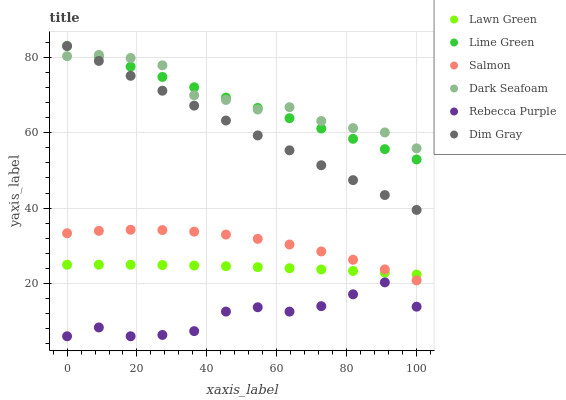Does Rebecca Purple have the minimum area under the curve?
Answer yes or no. Yes. Does Dark Seafoam have the maximum area under the curve?
Answer yes or no. Yes. Does Dim Gray have the minimum area under the curve?
Answer yes or no. No. Does Dim Gray have the maximum area under the curve?
Answer yes or no. No. Is Lime Green the smoothest?
Answer yes or no. Yes. Is Rebecca Purple the roughest?
Answer yes or no. Yes. Is Dim Gray the smoothest?
Answer yes or no. No. Is Dim Gray the roughest?
Answer yes or no. No. Does Rebecca Purple have the lowest value?
Answer yes or no. Yes. Does Dim Gray have the lowest value?
Answer yes or no. No. Does Lime Green have the highest value?
Answer yes or no. Yes. Does Salmon have the highest value?
Answer yes or no. No. Is Salmon less than Dim Gray?
Answer yes or no. Yes. Is Dark Seafoam greater than Salmon?
Answer yes or no. Yes. Does Dark Seafoam intersect Lime Green?
Answer yes or no. Yes. Is Dark Seafoam less than Lime Green?
Answer yes or no. No. Is Dark Seafoam greater than Lime Green?
Answer yes or no. No. Does Salmon intersect Dim Gray?
Answer yes or no. No. 